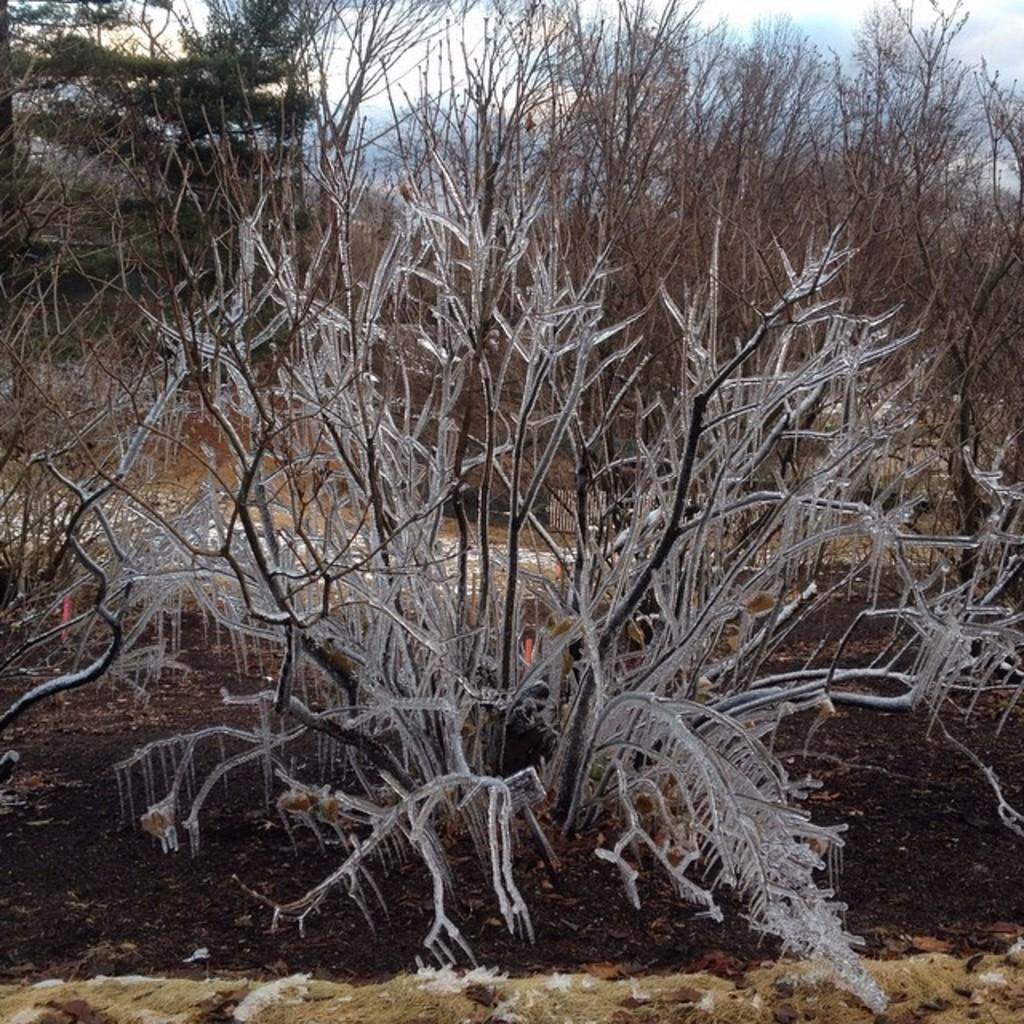What is the main subject of the image? The main subject of the image is a dried plant with ice on it. Are there any other dried plants visible in the image? Yes, there are dried plants in the background of the image. What type of camp can be seen in the image? There is no camp present in the image; it features a dried plant with ice on it and dried plants in the background. How many firemen are visible in the image? There are no firemen present in the image. 